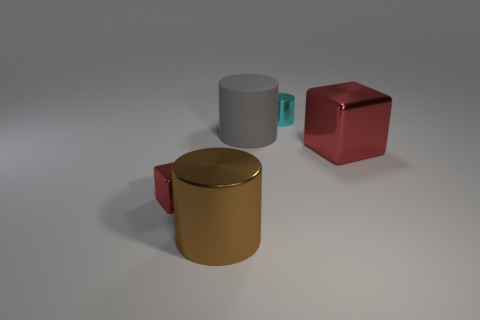Subtract all big cylinders. How many cylinders are left? 1 Add 2 big yellow cylinders. How many objects exist? 7 Subtract all gray cylinders. How many cylinders are left? 2 Subtract 2 blocks. How many blocks are left? 0 Subtract all blocks. How many objects are left? 3 Subtract all brown spheres. How many gray blocks are left? 0 Subtract all tiny brown matte blocks. Subtract all rubber objects. How many objects are left? 4 Add 2 large metal blocks. How many large metal blocks are left? 3 Add 1 large red blocks. How many large red blocks exist? 2 Subtract 0 blue spheres. How many objects are left? 5 